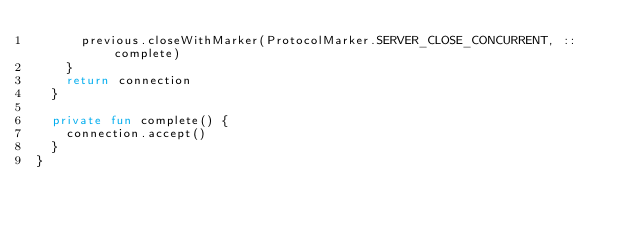<code> <loc_0><loc_0><loc_500><loc_500><_Kotlin_>			previous.closeWithMarker(ProtocolMarker.SERVER_CLOSE_CONCURRENT, ::complete)
		}
		return connection
	}
	
	private fun complete() {
		connection.accept()
	}
}</code> 